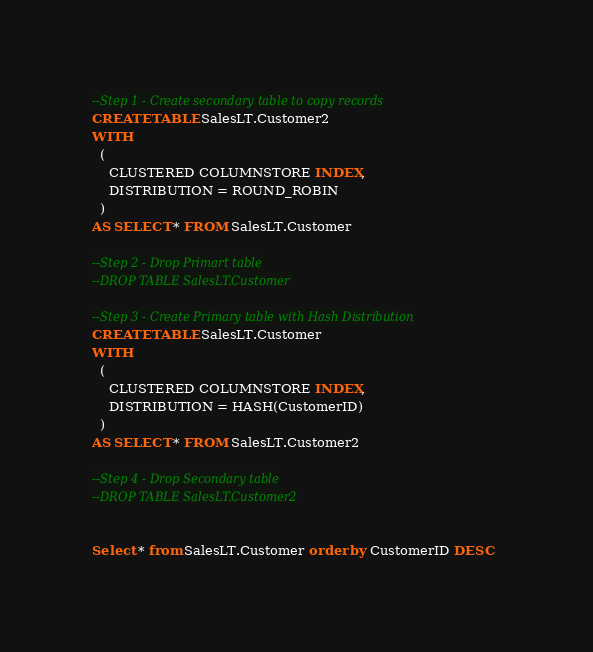<code> <loc_0><loc_0><loc_500><loc_500><_SQL_>--Step 1 - Create secondary table to copy records
CREATE TABLE SalesLT.Customer2  
WITH   
  (   
    CLUSTERED COLUMNSTORE INDEX,  
    DISTRIBUTION = ROUND_ROBIN   
  )  
AS SELECT * FROM SalesLT.Customer

--Step 2 - Drop Primart table
--DROP TABLE SalesLT.Customer

--Step 3 - Create Primary table with Hash Distribution
CREATE TABLE SalesLT.Customer  
WITH   
  (   
    CLUSTERED COLUMNSTORE INDEX,  
    DISTRIBUTION = HASH(CustomerID) 
  )  
AS SELECT * FROM SalesLT.Customer2

--Step 4 - Drop Secondary table
--DROP TABLE SalesLT.Customer2


Select * from SalesLT.Customer order by CustomerID DESC  </code> 